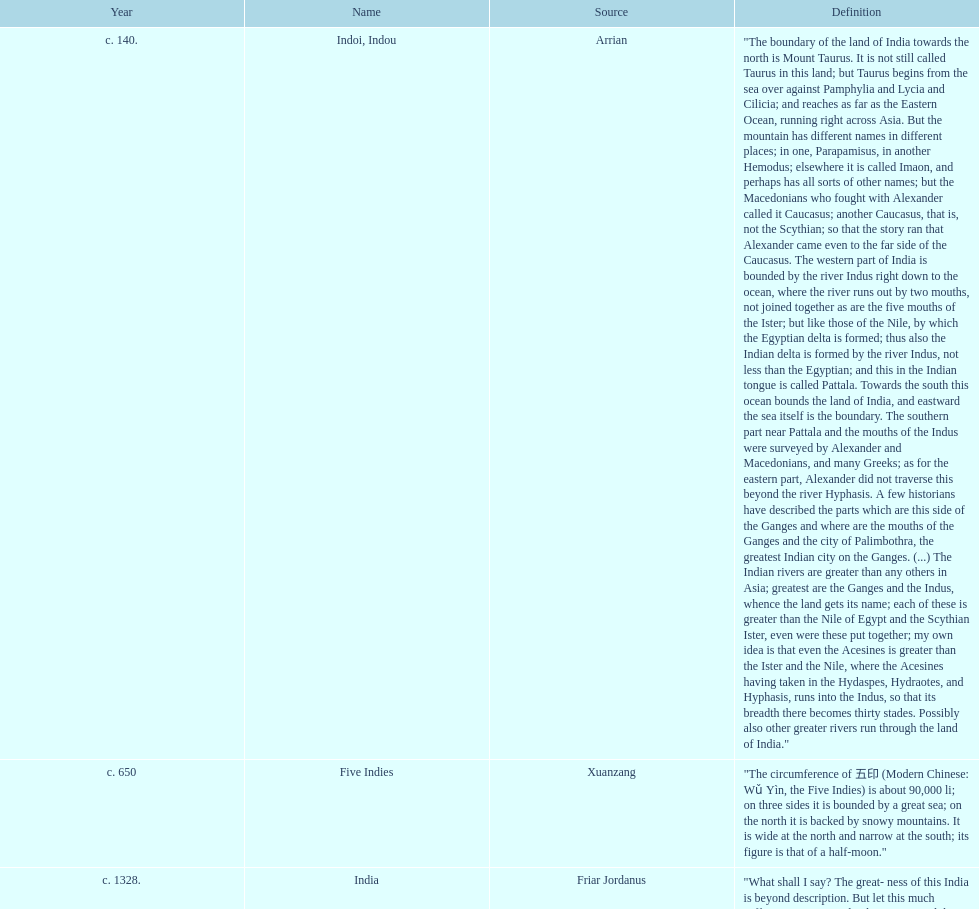Which is the most recent source for the name? Clavijo. 